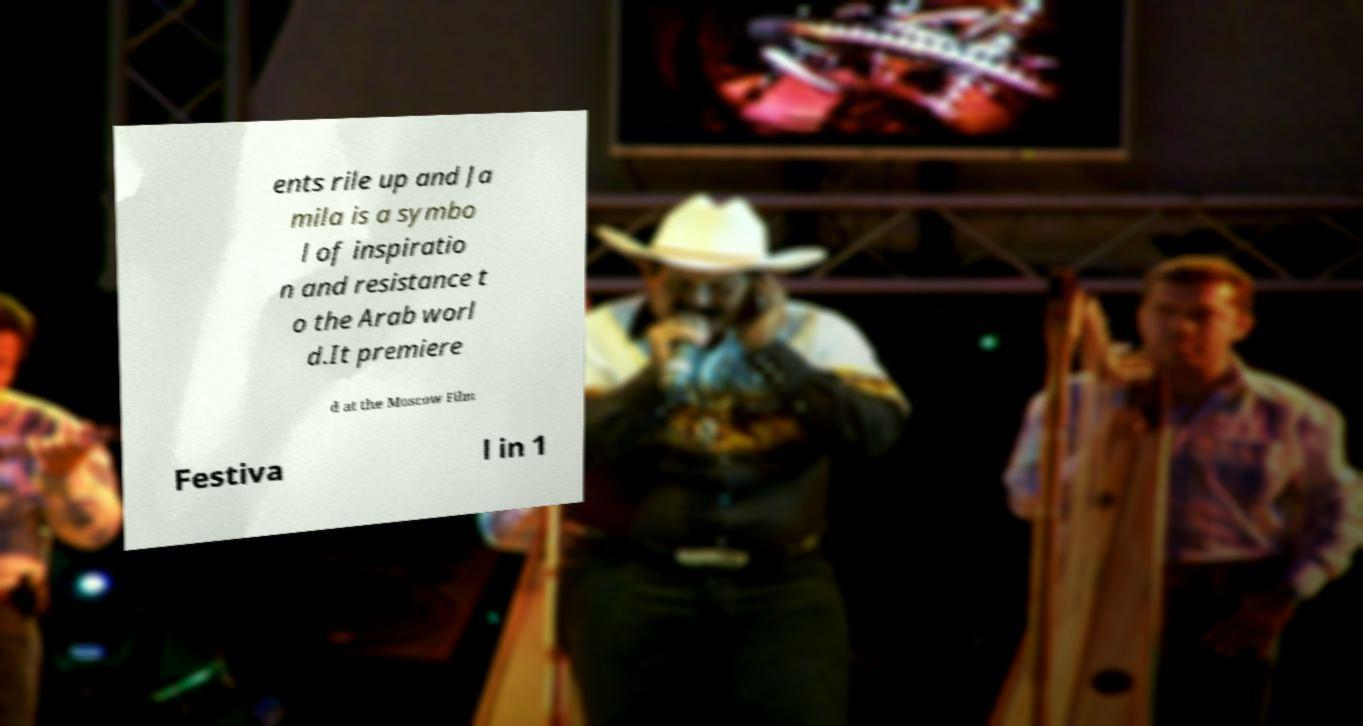Can you read and provide the text displayed in the image?This photo seems to have some interesting text. Can you extract and type it out for me? ents rile up and Ja mila is a symbo l of inspiratio n and resistance t o the Arab worl d.It premiere d at the Moscow Film Festiva l in 1 